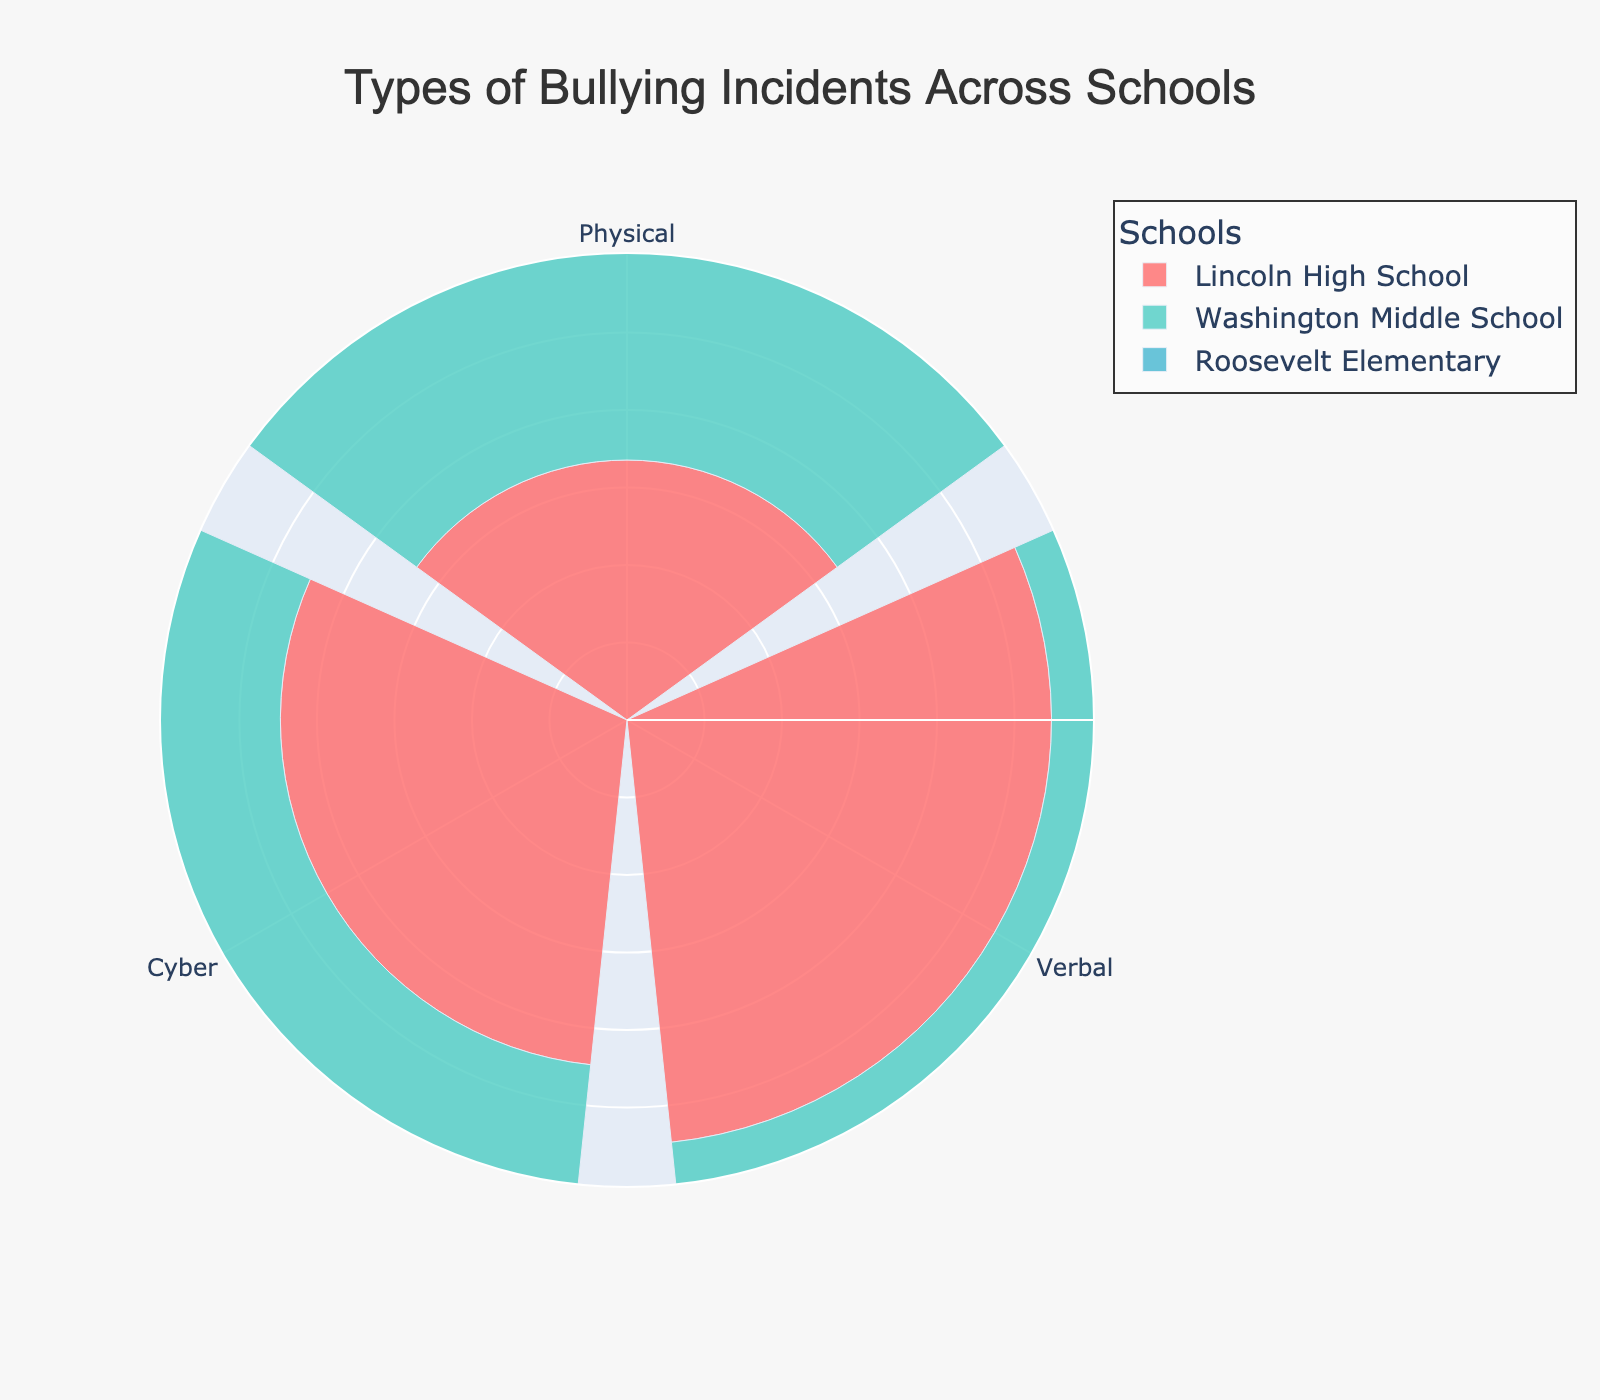What is the title of the figure? The title is usually placed at the top center of the figure. The text is "Types of Bullying Incidents Across Schools".
Answer: Types of Bullying Incidents Across Schools How many types of bullying are represented in the figure? The figure shows three distinct segments or labels in each group, which corresponds to the types of bullying.
Answer: Three Which school has the highest number of verbal bullying incidents? By comparing the size and hover text for each school's verbal bullying segment, Lincoln High School has the highest number with 120 incidents.
Answer: Lincoln High School Which school has the lowest number of physical bullying incidents? By comparing the sizes of the physical bullying segments for each school, Roosevelt Elementary has the lowest number with 25 incidents.
Answer: Roosevelt Elementary Compare the number of cyber bullying incidents between Lincoln High School and Washington Middle School. Lincoln High School has 80 cyber bullying incidents and Washington Middle School has 95. Washington Middle School has 15 more cyber bullying incidents than Lincoln High School.
Answer: Washington Middle School What is the total number of bullying incidents reported in Roosevelt Elementary? By summing up the incidents of each type at Roosevelt Elementary: 25 (physical) + 60 (verbal) + 55 (cyber) = 140 incidents.
Answer: 140 Which type of bullying has the highest overall incidence across all schools? By adding up each type of incident from all schools: Physical (45+30+25=100), Verbal (120+75+60=255), Cyber (80+95+55=230). Verbal bullying has the highest total.
Answer: Verbal How many more verbal bullying incidents are there compared to physical bullying incidents at Lincoln High School? Subtract the number of physical incidents from verbal incidents at Lincoln High School: 120 (verbal) - 45 (physical) = 75 incidents.
Answer: 75 What is the average number of bullying incidents per type at Washington Middle School? Sum the incidents at Washington Middle School and divide by the number of types: (30+75+95)/3 = 66.67.
Answer: 66.67 Which type of bullying has the smallest difference in incident count between Lincoln High School and Roosevelt Elementary? Calculate the difference in incident counts for each type: Physical (45-25=20), Verbal (120-60=60), Cyber (80-55=25). Physical bullying has the smallest difference of 20 incidents.
Answer: Physical 